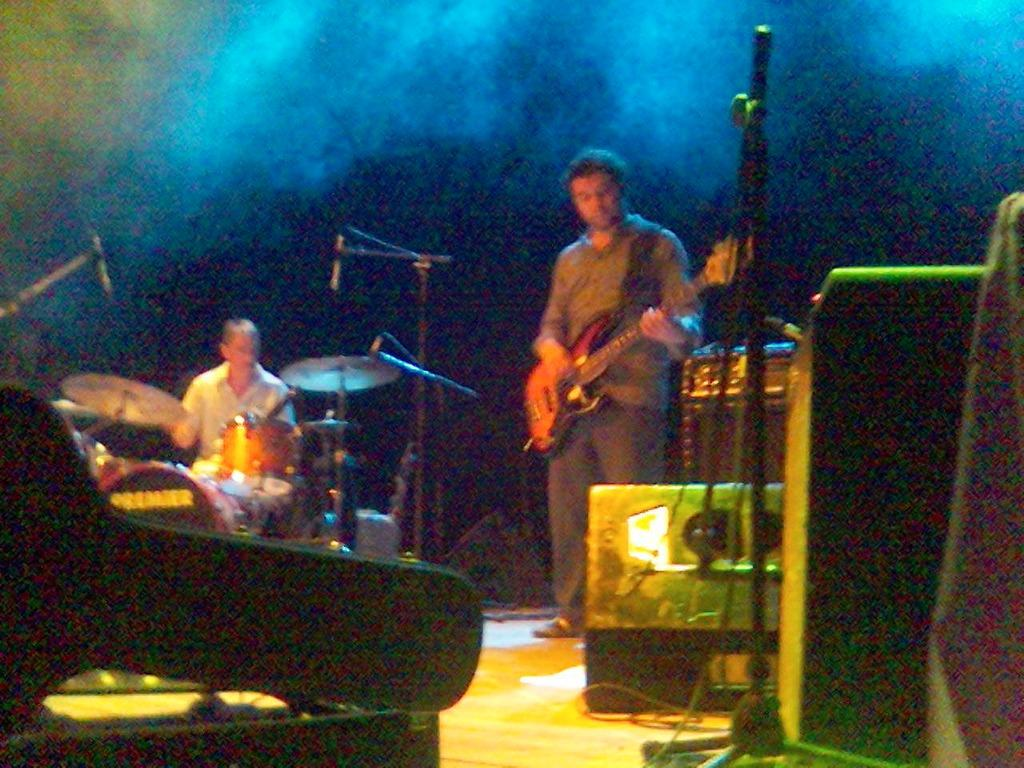How many musicians are present in the image? There are two musicians in the image. What are the musicians doing in the image? The musicians are playing musical instruments. What device is present in front of the musicians? There is a microphone in front of the musicians. What type of curve can be seen on the chalkboard in the image? There is no chalkboard present in the image, so it is not possible to determine if there is a curve or not. 